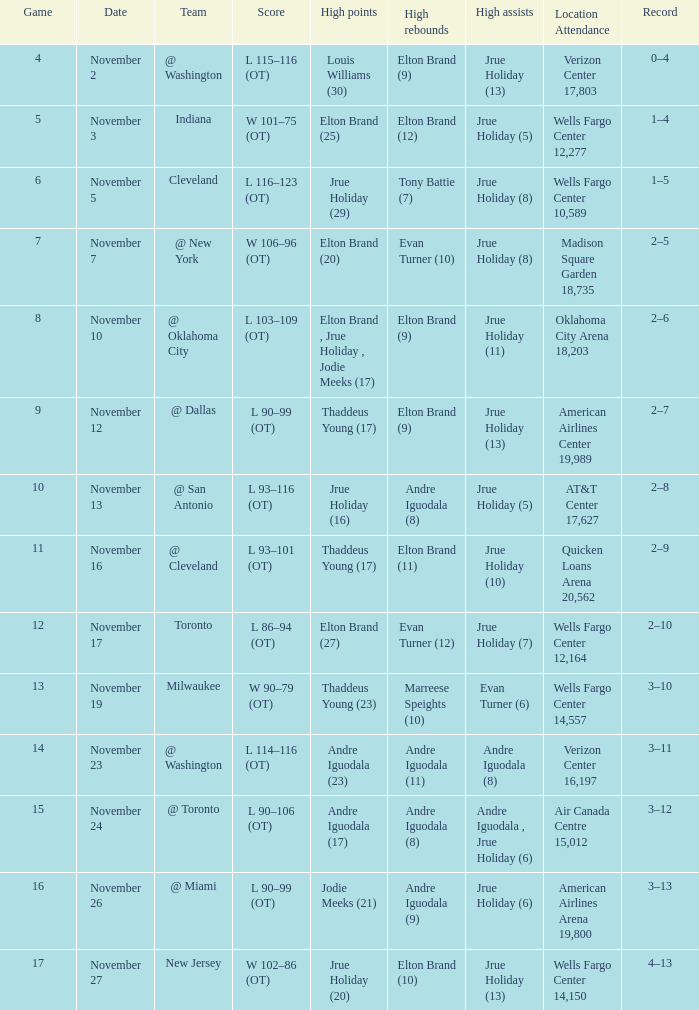How many games are shown for the game where andre iguodala (9) had the high rebounds? 1.0. 